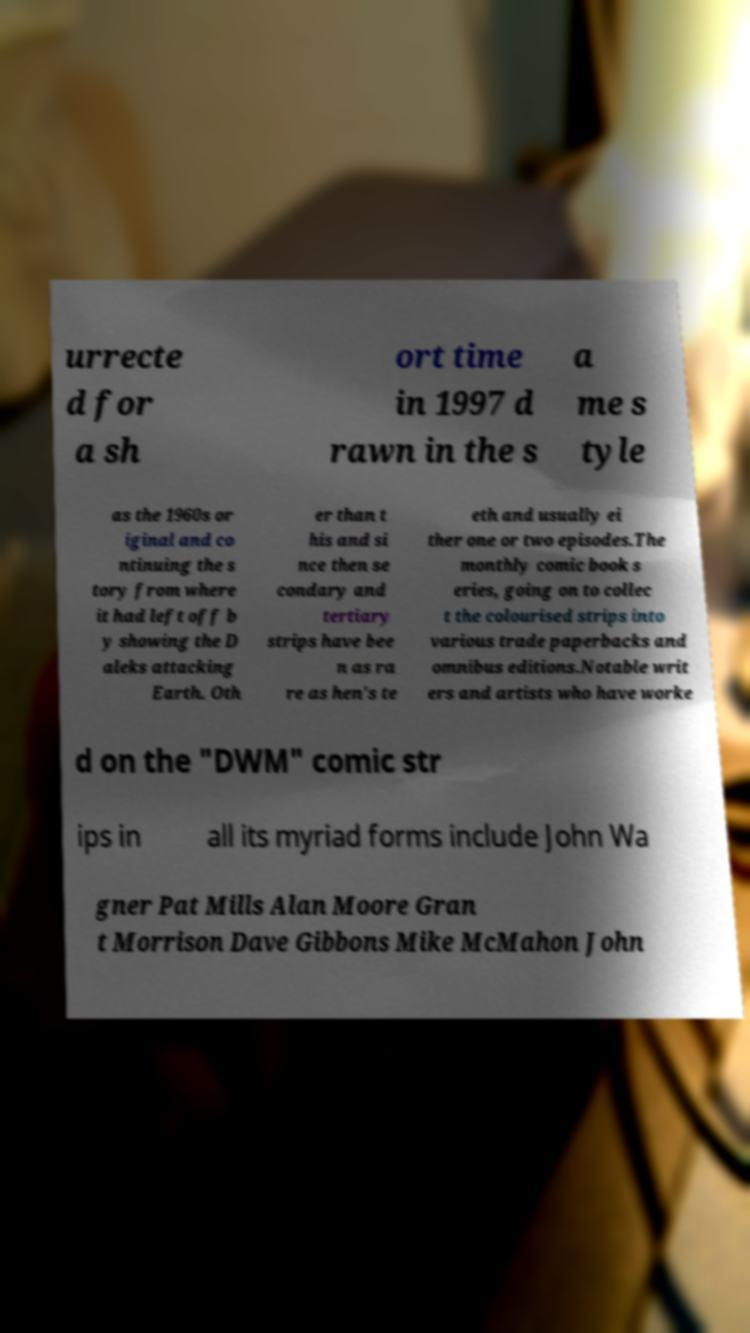There's text embedded in this image that I need extracted. Can you transcribe it verbatim? urrecte d for a sh ort time in 1997 d rawn in the s a me s tyle as the 1960s or iginal and co ntinuing the s tory from where it had left off b y showing the D aleks attacking Earth. Oth er than t his and si nce then se condary and tertiary strips have bee n as ra re as hen's te eth and usually ei ther one or two episodes.The monthly comic book s eries, going on to collec t the colourised strips into various trade paperbacks and omnibus editions.Notable writ ers and artists who have worke d on the "DWM" comic str ips in all its myriad forms include John Wa gner Pat Mills Alan Moore Gran t Morrison Dave Gibbons Mike McMahon John 